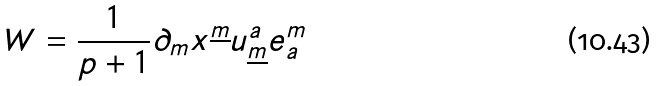Convert formula to latex. <formula><loc_0><loc_0><loc_500><loc_500>W = \frac { 1 } { p + 1 } \partial _ { m } x ^ { \underline { m } } u _ { \underline { m } } ^ { a } e _ { a } ^ { m }</formula> 